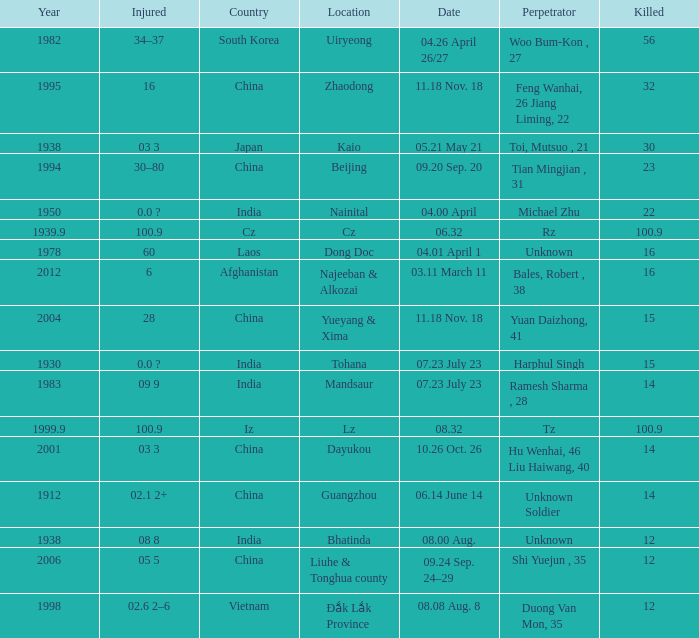What is Injured, when Country is "Afghanistan"? 6.0. 